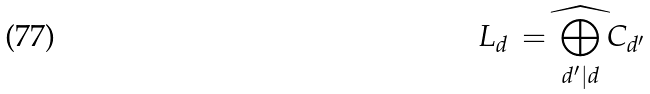Convert formula to latex. <formula><loc_0><loc_0><loc_500><loc_500>L _ { d } \, = \, \widehat { \bigoplus _ { d ^ { \prime } | d } } \, C _ { d ^ { \prime } }</formula> 